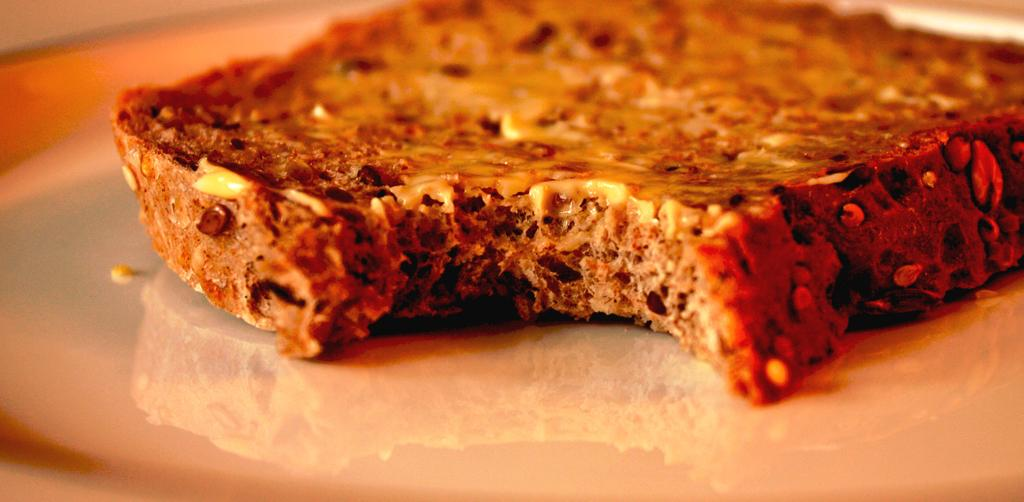What is the main subject in the foreground of the image? There is a bread in the foreground of the image. What type of page is visible in the image? There is no page present in the image; it features a bread in the foreground. How many boxes can be seen in the image? There are no boxes present in the image; it features a bread in the foreground. 